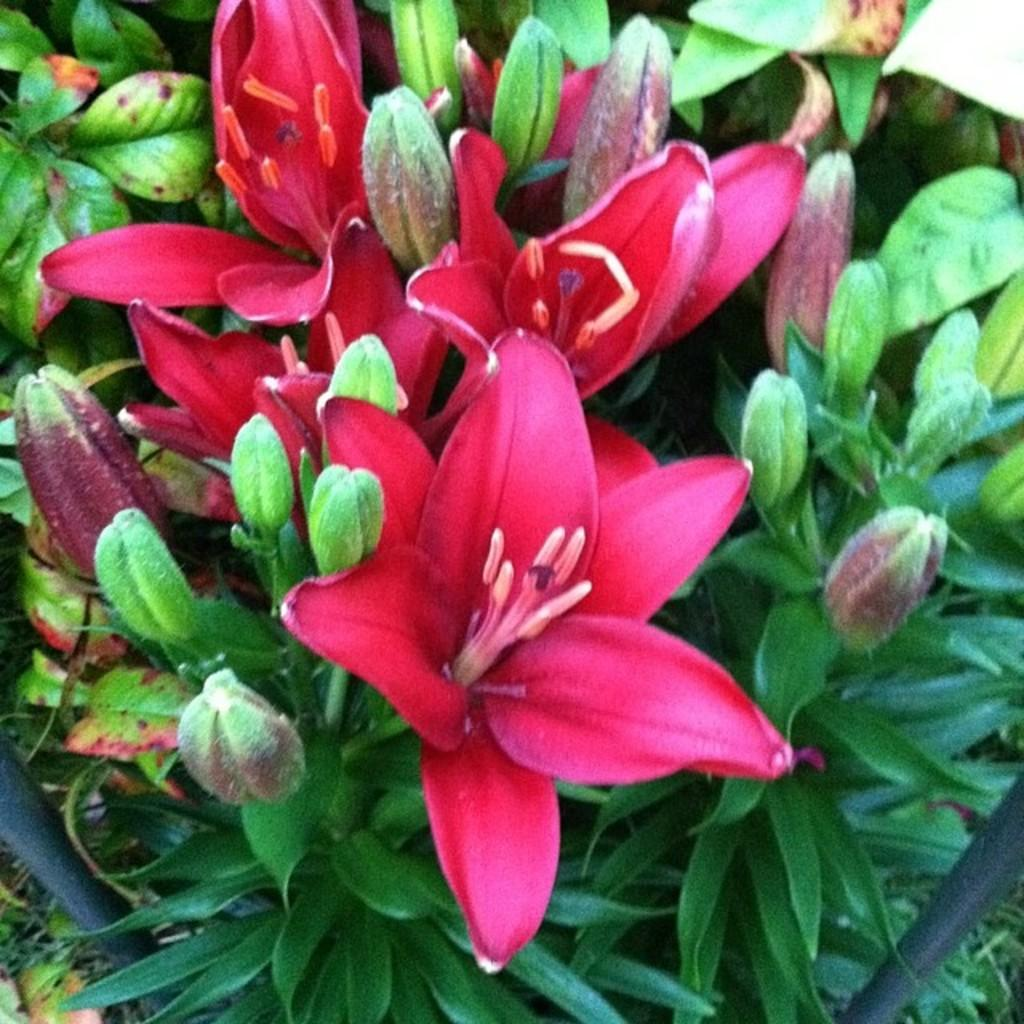What type of plant life is depicted in the image? There are flowers and leaves in the image. What are the flowers made up of? The flowers have petals, which are visible in the image. Are there any other small particles visible in the image? Yes, pollen grains are visible in the image. What type of bells can be heard ringing in the image? There are no bells present in the image, and therefore no sound can be heard. 